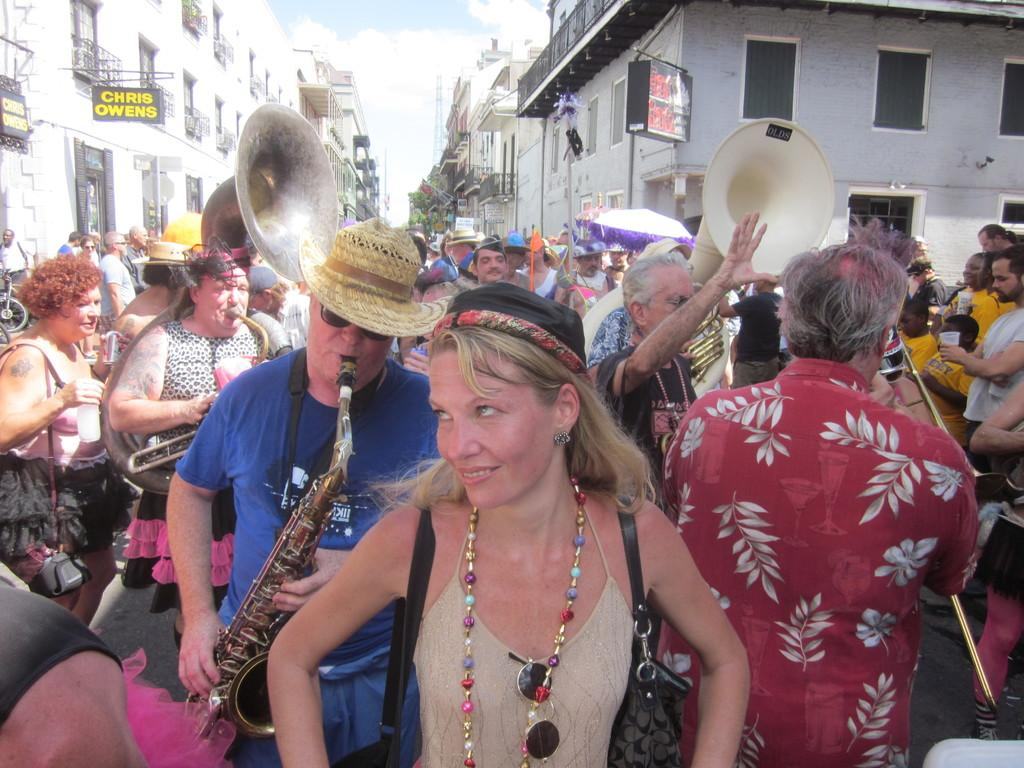How many people are in the image? There is a group of people standing in the image. What are some of the people doing in the image? Some people are holding musical instruments. What objects can be seen in the image besides the people? There are boards, buildings, and trees in the image. What can be seen in the background of the image? The sky is visible in the background of the image. What type of zinc is being used to create the boards in the image? There is no mention of zinc or any specific materials used for the boards in the image. 